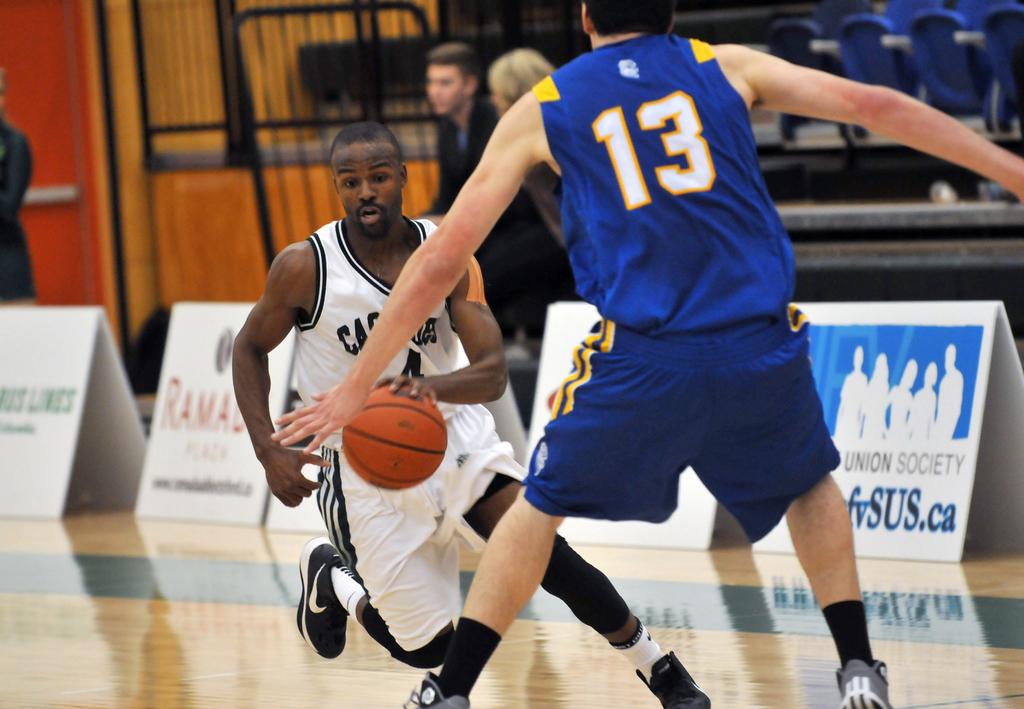What number is the man in blue?
Your answer should be compact. 13. 